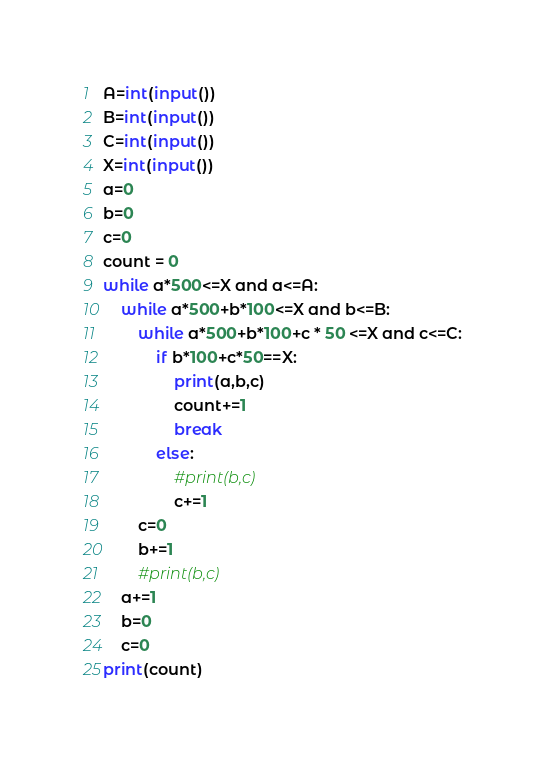<code> <loc_0><loc_0><loc_500><loc_500><_Python_>A=int(input())
B=int(input())
C=int(input())
X=int(input())
a=0
b=0
c=0
count = 0
while a*500<=X and a<=A:
    while a*500+b*100<=X and b<=B:
        while a*500+b*100+c * 50 <=X and c<=C:
            if b*100+c*50==X:
                print(a,b,c)
                count+=1
                break
            else:
                #print(b,c)
                c+=1
        c=0
        b+=1
        #print(b,c)
    a+=1
    b=0
    c=0
print(count)
</code> 